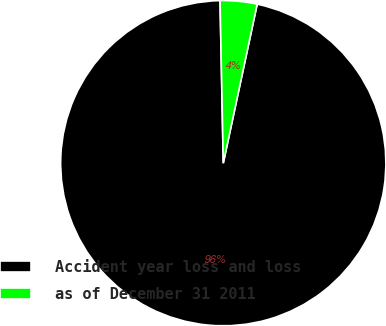Convert chart to OTSL. <chart><loc_0><loc_0><loc_500><loc_500><pie_chart><fcel>Accident year loss and loss<fcel>as of December 31 2011<nl><fcel>96.34%<fcel>3.66%<nl></chart> 